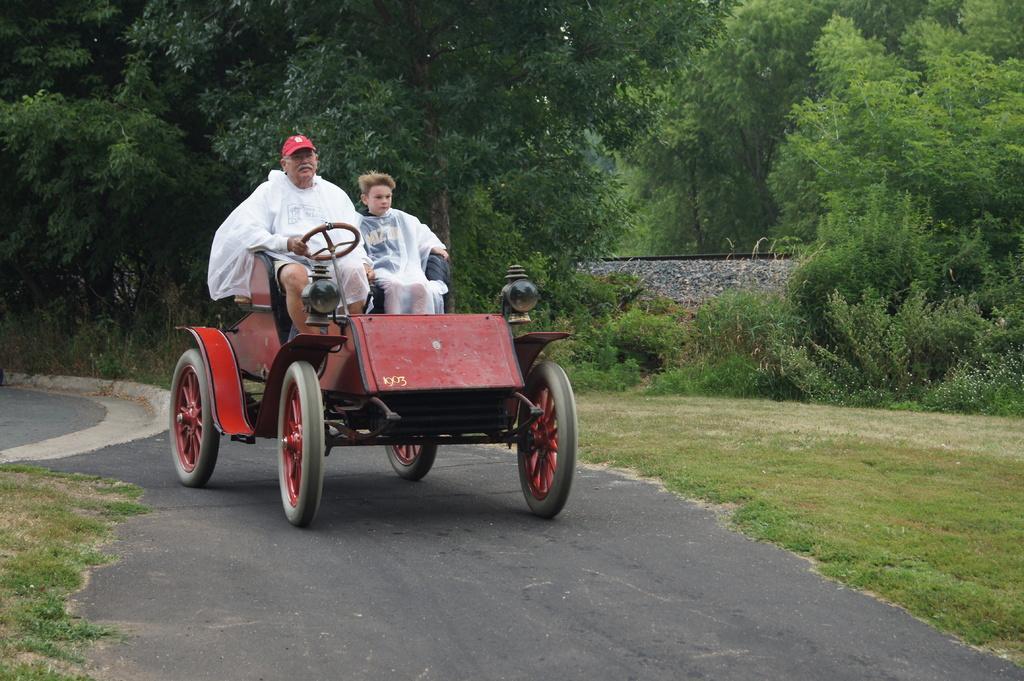Can you describe this image briefly? In this image there is a person and a boy wearing raincoat are sitting and riding a vehicle on the road. There is grass on both sides of the vehicle. There are few plants and trees at the background of image. Person is wearing a red colour cap on his head. 